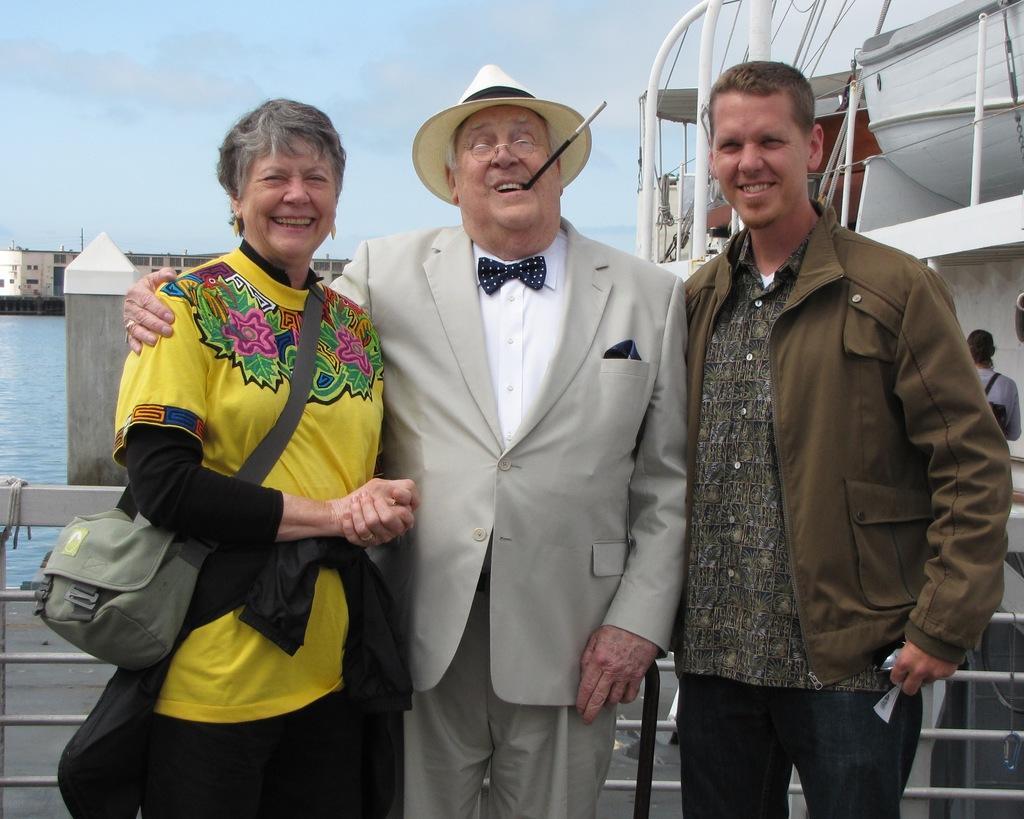In one or two sentences, can you explain what this image depicts? In this image, on the right there is a man, he wears a jacket, shirt, trouser. In the middle there is a man, he wears a suit, shirt, trouser. On the left there is a woman, she wears a t shirt, trouser, bag. In the background there is a boat, person, water, stone, sky and clouds. 